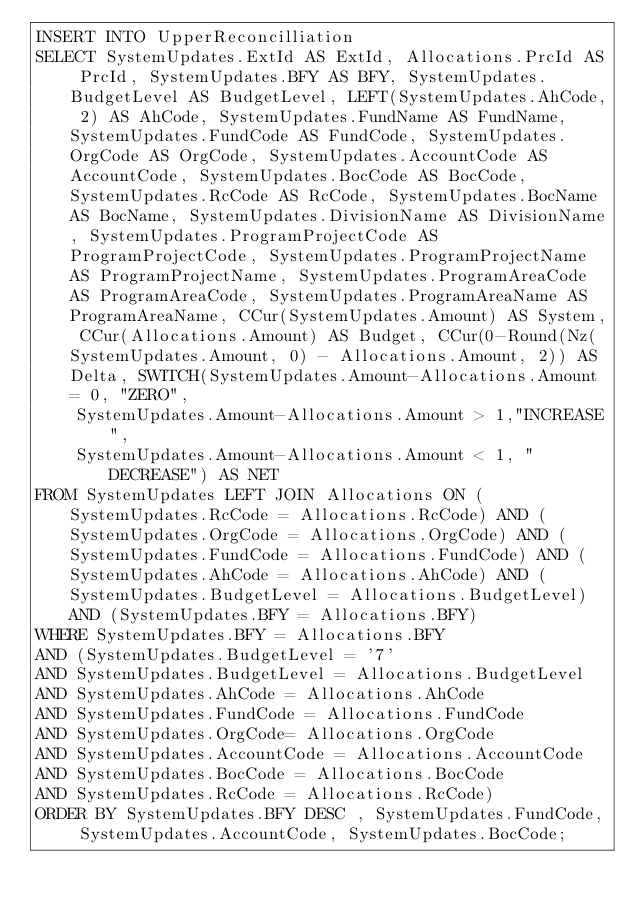Convert code to text. <code><loc_0><loc_0><loc_500><loc_500><_SQL_>INSERT INTO UpperReconcilliation
SELECT SystemUpdates.ExtId AS ExtId, Allocations.PrcId AS PrcId, SystemUpdates.BFY AS BFY, SystemUpdates.BudgetLevel AS BudgetLevel, LEFT(SystemUpdates.AhCode, 2) AS AhCode, SystemUpdates.FundName AS FundName, SystemUpdates.FundCode AS FundCode, SystemUpdates.OrgCode AS OrgCode, SystemUpdates.AccountCode AS AccountCode, SystemUpdates.BocCode AS BocCode, SystemUpdates.RcCode AS RcCode, SystemUpdates.BocName AS BocName, SystemUpdates.DivisionName AS DivisionName, SystemUpdates.ProgramProjectCode AS ProgramProjectCode, SystemUpdates.ProgramProjectName AS ProgramProjectName, SystemUpdates.ProgramAreaCode AS ProgramAreaCode, SystemUpdates.ProgramAreaName AS ProgramAreaName, CCur(SystemUpdates.Amount) AS System, CCur(Allocations.Amount) AS Budget, CCur(0-Round(Nz(SystemUpdates.Amount, 0) - Allocations.Amount, 2)) AS Delta, SWITCH(SystemUpdates.Amount-Allocations.Amount = 0, "ZERO", 
    SystemUpdates.Amount-Allocations.Amount > 1,"INCREASE",
    SystemUpdates.Amount-Allocations.Amount < 1, "DECREASE") AS NET
FROM SystemUpdates LEFT JOIN Allocations ON (SystemUpdates.RcCode = Allocations.RcCode) AND (SystemUpdates.OrgCode = Allocations.OrgCode) AND (SystemUpdates.FundCode = Allocations.FundCode) AND (SystemUpdates.AhCode = Allocations.AhCode) AND (SystemUpdates.BudgetLevel = Allocations.BudgetLevel) AND (SystemUpdates.BFY = Allocations.BFY)
WHERE SystemUpdates.BFY = Allocations.BFY
AND (SystemUpdates.BudgetLevel = '7' 
AND SystemUpdates.BudgetLevel = Allocations.BudgetLevel
AND SystemUpdates.AhCode = Allocations.AhCode
AND SystemUpdates.FundCode = Allocations.FundCode 
AND SystemUpdates.OrgCode= Allocations.OrgCode
AND SystemUpdates.AccountCode = Allocations.AccountCode 
AND SystemUpdates.BocCode = Allocations.BocCode 
AND SystemUpdates.RcCode = Allocations.RcCode)
ORDER BY SystemUpdates.BFY DESC , SystemUpdates.FundCode, SystemUpdates.AccountCode, SystemUpdates.BocCode;


</code> 